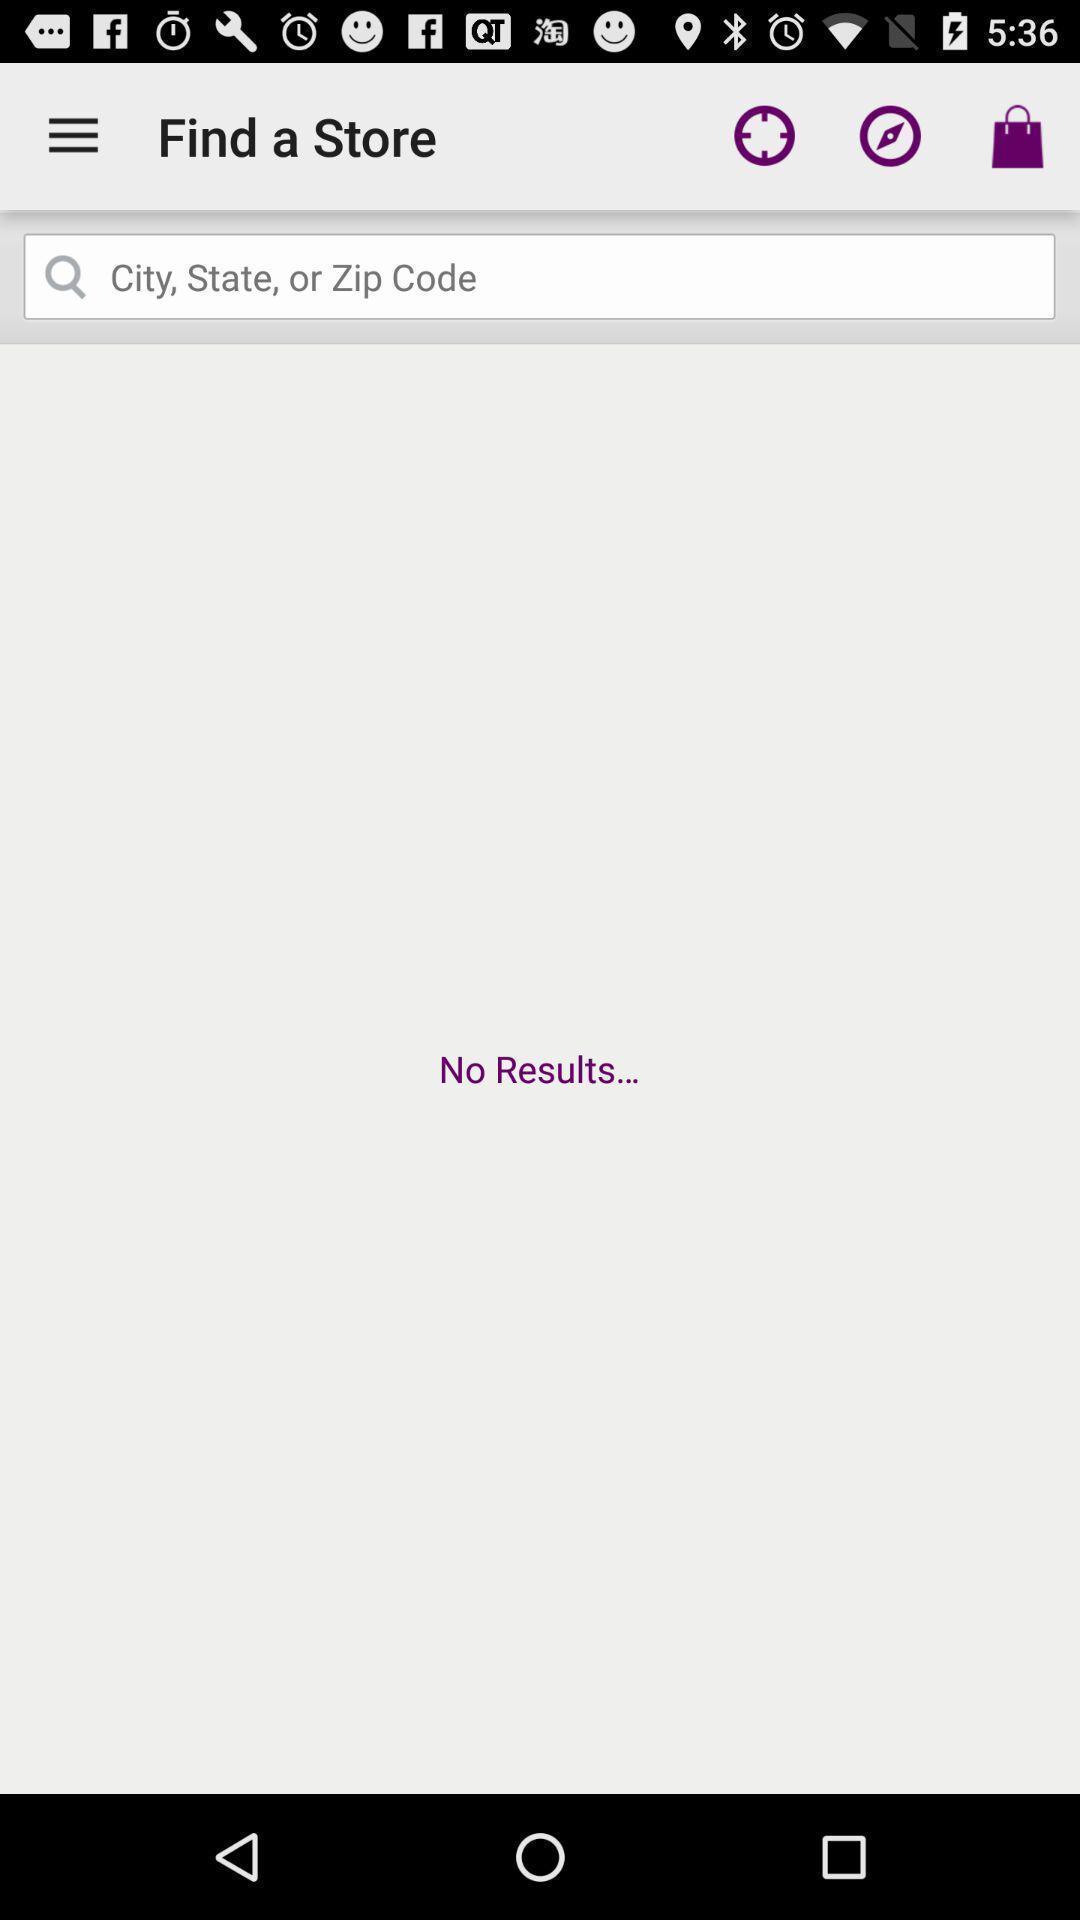Describe the content in this image. Search page for finding nearby stores on shopping app. 